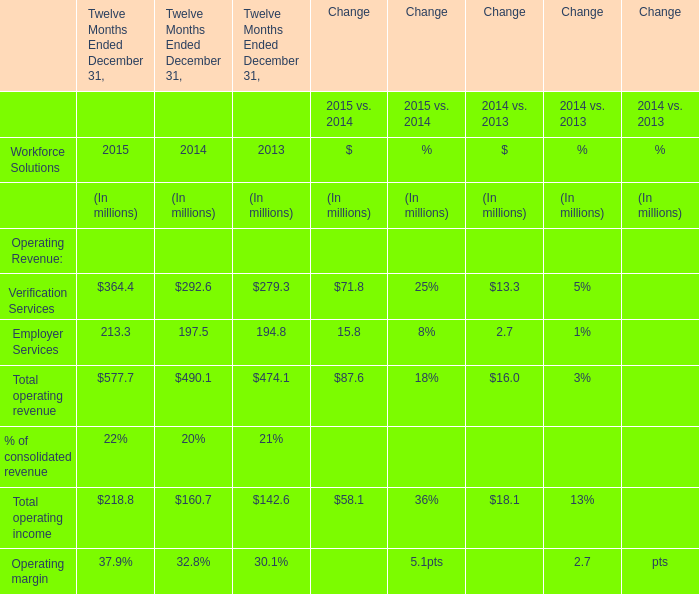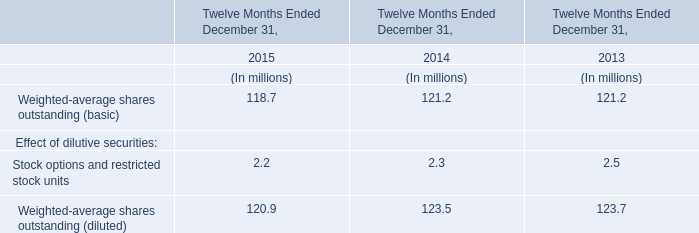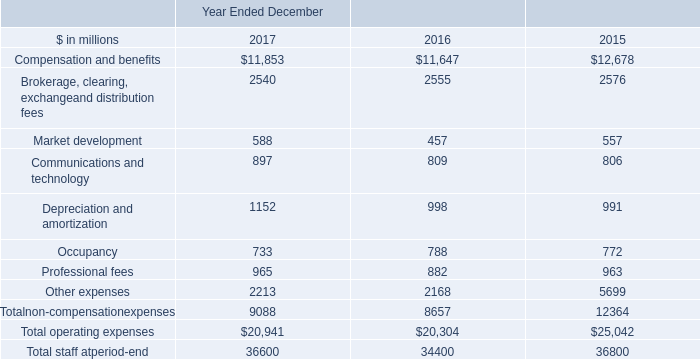In the year with the most Total operating revenue, what is the growth rate of Total operating income? 
Computations: ((218.8 - 160.7) / 160.7)
Answer: 0.36154. 